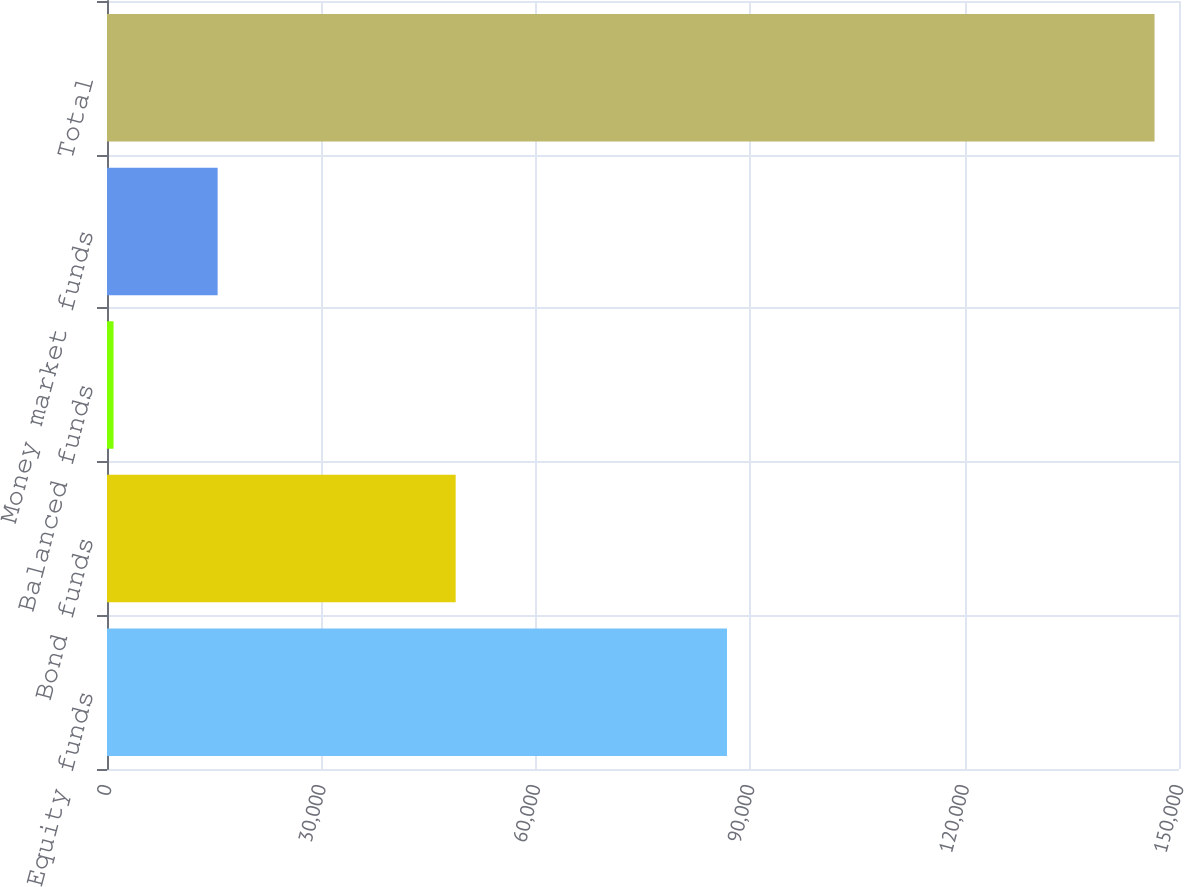Convert chart. <chart><loc_0><loc_0><loc_500><loc_500><bar_chart><fcel>Equity funds<fcel>Bond funds<fcel>Balanced funds<fcel>Money market funds<fcel>Total<nl><fcel>86751<fcel>48789<fcel>914<fcel>15480.4<fcel>146578<nl></chart> 